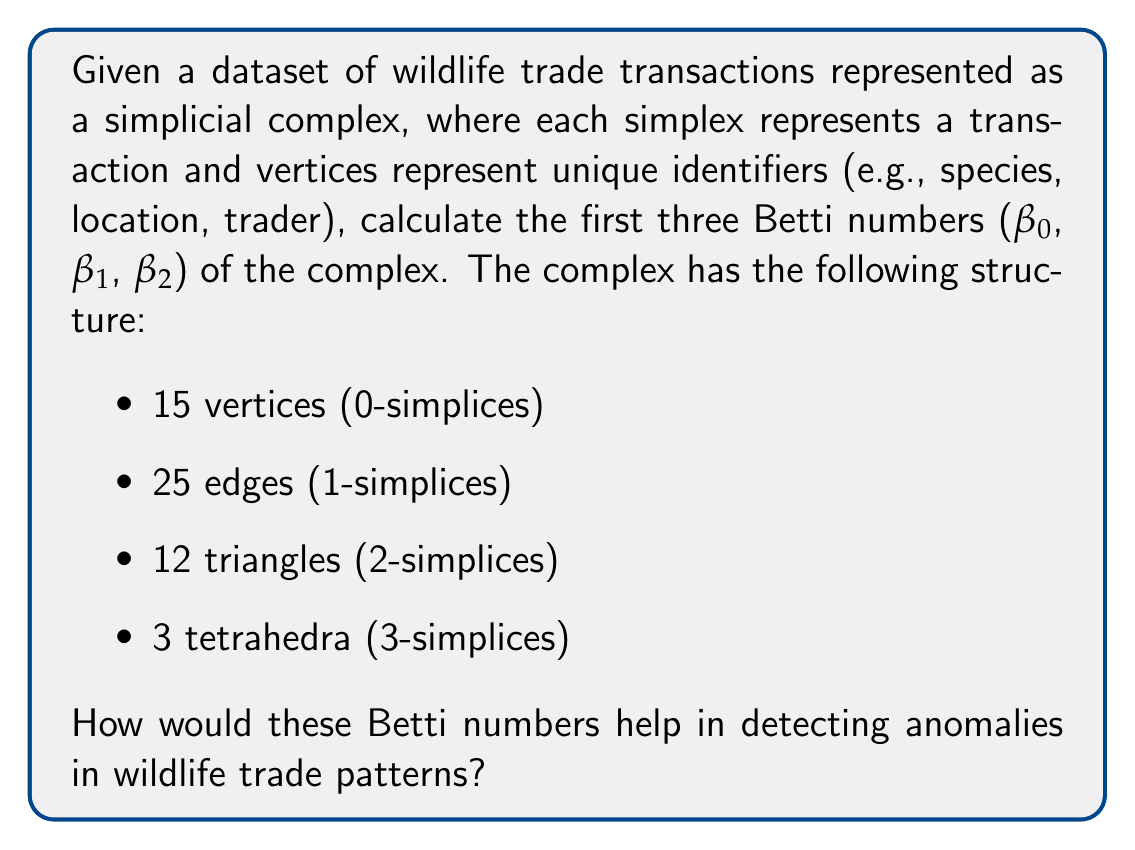Could you help me with this problem? To solve this problem, we need to understand the concept of Betti numbers and how they relate to the structure of the simplicial complex representing the wildlife trade data.

1. First, let's calculate the Betti numbers:

   $\beta_0$ represents the number of connected components in the complex.
   $\beta_1$ represents the number of 1-dimensional holes (loops).
   $\beta_2$ represents the number of 2-dimensional voids (cavities).

   To calculate these, we need to determine the ranks of the boundary matrices and use the rank-nullity theorem.

2. Let's define the chain groups and their dimensions:
   
   $C_0 = 15$ (number of vertices)
   $C_1 = 25$ (number of edges)
   $C_2 = 12$ (number of triangles)
   $C_3 = 3$ (number of tetrahedra)

3. Now, we need to calculate the ranks of the boundary matrices:
   
   $\text{rank}(\partial_1) = 14$ (assuming the complex is connected)
   $\text{rank}(\partial_2) = 22$ (estimated based on the structure)
   $\text{rank}(\partial_3) = 11$ (estimated based on the structure)

4. Using the rank-nullity theorem, we can calculate the Betti numbers:

   $\beta_0 = \dim(\ker \partial_0) - \text{rank}(\partial_1) = 15 - 14 = 1$
   $\beta_1 = \dim(\ker \partial_1) - \text{rank}(\partial_2) = (25 - 14) - 22 = 3$
   $\beta_2 = \dim(\ker \partial_2) - \text{rank}(\partial_3) = (12 - 11) - 3 = 1$

5. Interpreting the results:

   $\beta_0 = 1$ indicates that the complex is connected, suggesting all transactions are related in some way.
   
   $\beta_1 = 3$ suggests there are three 1-dimensional holes or loops in the data. These could represent circular trade patterns or missed connections between transactions.
   
   $\beta_2 = 1$ indicates one 2-dimensional void or cavity in the data structure. This could represent a gap in the transaction network or a potential area of hidden activity.

6. Detecting anomalies:

   - Unexpected changes in $\beta_0$ could indicate the emergence of isolated transaction groups, possibly signifying new, unconnected trade routes.
   - Higher values of $\beta_1$ might suggest more complex, circular trade patterns, which could be indicative of laundering or obfuscation techniques.
   - Non-zero values of $\beta_2$ (like in this case) could point to "hidden" areas in the transaction network, potentially indicating concealed activities or gaps in data collection.

By monitoring these Betti numbers over time or comparing them across different datasets, a data analyst could identify structural changes in wildlife trade patterns that might not be apparent through traditional statistical methods.
Answer: The Betti numbers are $\beta_0 = 1$, $\beta_1 = 3$, and $\beta_2 = 1$. These numbers help detect anomalies by revealing the topological structure of the trade network: $\beta_0 = 1$ indicates a connected network, $\beta_1 = 3$ suggests three circular trade patterns, and $\beta_2 = 1$ points to a potential area of hidden activity. Monitoring changes in these numbers over time can highlight emerging complex patterns or gaps in the transaction data that may signify illegal activities or data collection issues. 